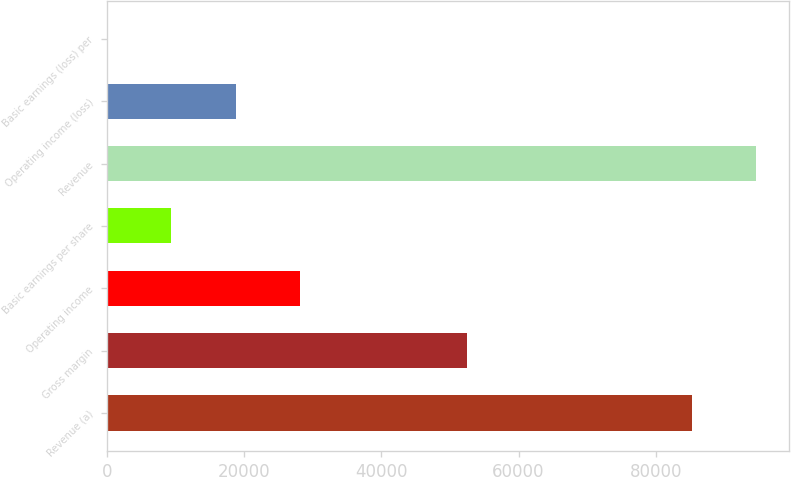Convert chart. <chart><loc_0><loc_0><loc_500><loc_500><bar_chart><fcel>Revenue (a)<fcel>Gross margin<fcel>Operating income<fcel>Basic earnings per share<fcel>Revenue<fcel>Operating income (loss)<fcel>Basic earnings (loss) per<nl><fcel>85320<fcel>52540<fcel>28075<fcel>9359.34<fcel>94677.9<fcel>18717.2<fcel>1.49<nl></chart> 